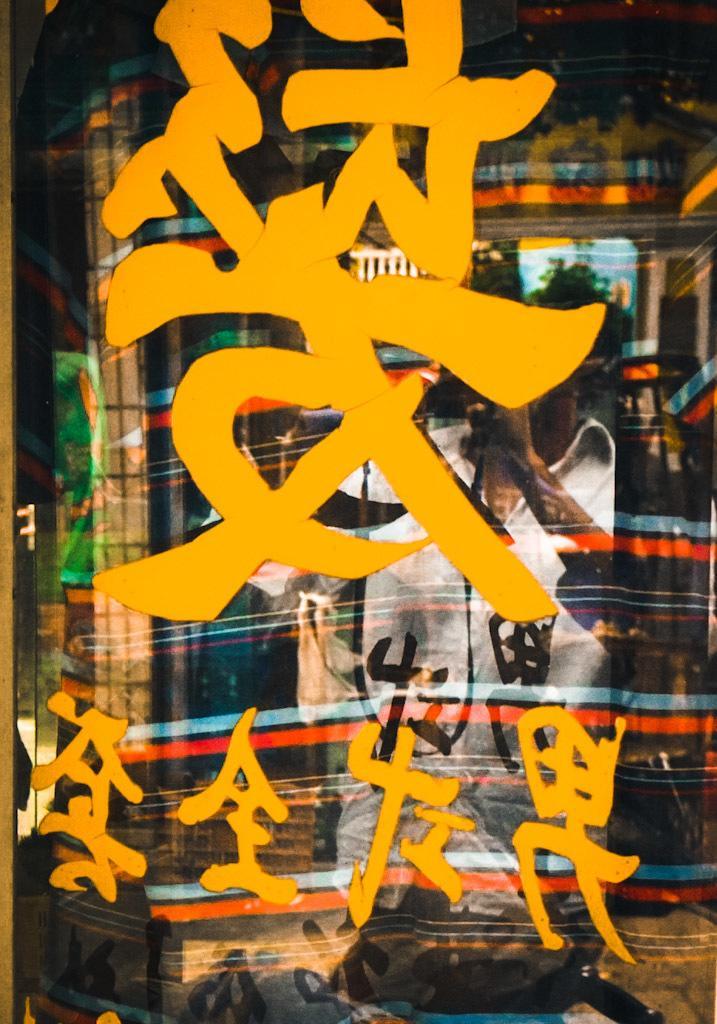Please provide a concise description of this image. In this image I can see the glass surface on which I can see something is written with yellow color. On the glass I can see the reflection of a person wearing white colored dress. 